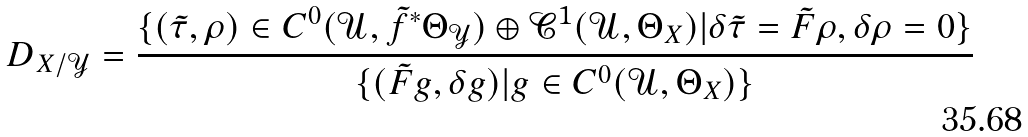Convert formula to latex. <formula><loc_0><loc_0><loc_500><loc_500>D _ { X / \mathcal { Y } } = \frac { \{ ( \tilde { \tau } , \rho ) \in C ^ { 0 } ( \mathcal { U } , \tilde { f } ^ { * } \Theta _ { \mathcal { Y } } ) \oplus \mathcal { C } ^ { 1 } ( \mathcal { U } , \Theta _ { X } ) | \delta \tilde { \tau } = \tilde { F } \rho , \delta \rho = 0 \} } { \{ ( \tilde { F } g , \delta g ) | g \in C ^ { 0 } ( \mathcal { U } , \Theta _ { X } ) \} }</formula> 